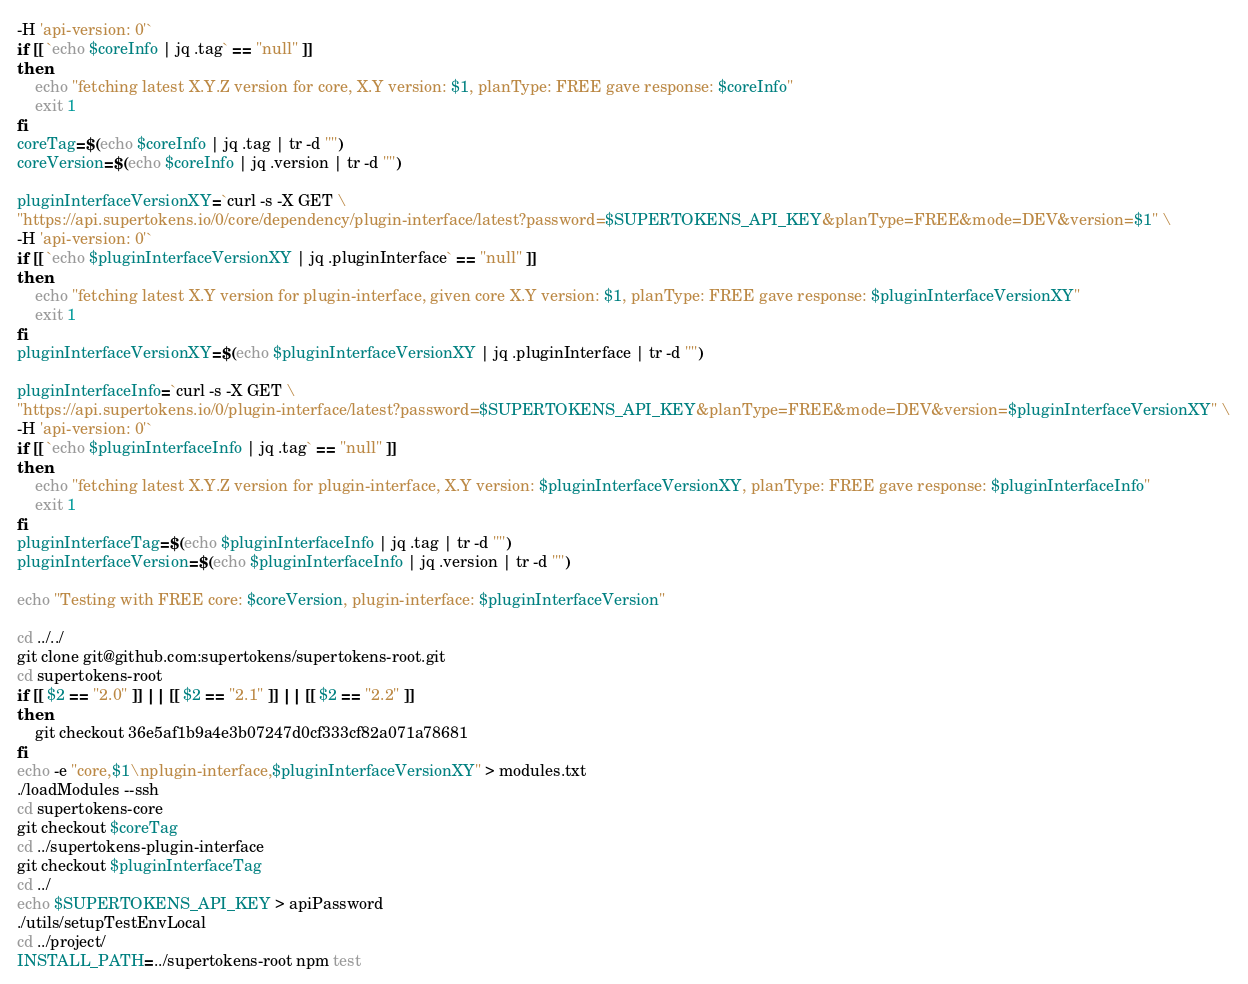<code> <loc_0><loc_0><loc_500><loc_500><_Bash_>-H 'api-version: 0'`
if [[ `echo $coreInfo | jq .tag` == "null" ]]
then
    echo "fetching latest X.Y.Z version for core, X.Y version: $1, planType: FREE gave response: $coreInfo"
    exit 1
fi
coreTag=$(echo $coreInfo | jq .tag | tr -d '"')
coreVersion=$(echo $coreInfo | jq .version | tr -d '"')

pluginInterfaceVersionXY=`curl -s -X GET \
"https://api.supertokens.io/0/core/dependency/plugin-interface/latest?password=$SUPERTOKENS_API_KEY&planType=FREE&mode=DEV&version=$1" \
-H 'api-version: 0'`
if [[ `echo $pluginInterfaceVersionXY | jq .pluginInterface` == "null" ]]
then
    echo "fetching latest X.Y version for plugin-interface, given core X.Y version: $1, planType: FREE gave response: $pluginInterfaceVersionXY"
    exit 1
fi
pluginInterfaceVersionXY=$(echo $pluginInterfaceVersionXY | jq .pluginInterface | tr -d '"')

pluginInterfaceInfo=`curl -s -X GET \
"https://api.supertokens.io/0/plugin-interface/latest?password=$SUPERTOKENS_API_KEY&planType=FREE&mode=DEV&version=$pluginInterfaceVersionXY" \
-H 'api-version: 0'`
if [[ `echo $pluginInterfaceInfo | jq .tag` == "null" ]]
then
    echo "fetching latest X.Y.Z version for plugin-interface, X.Y version: $pluginInterfaceVersionXY, planType: FREE gave response: $pluginInterfaceInfo"
    exit 1
fi
pluginInterfaceTag=$(echo $pluginInterfaceInfo | jq .tag | tr -d '"')
pluginInterfaceVersion=$(echo $pluginInterfaceInfo | jq .version | tr -d '"')

echo "Testing with FREE core: $coreVersion, plugin-interface: $pluginInterfaceVersion"

cd ../../
git clone git@github.com:supertokens/supertokens-root.git
cd supertokens-root
if [[ $2 == "2.0" ]] || [[ $2 == "2.1" ]] || [[ $2 == "2.2" ]]
then
    git checkout 36e5af1b9a4e3b07247d0cf333cf82a071a78681
fi
echo -e "core,$1\nplugin-interface,$pluginInterfaceVersionXY" > modules.txt
./loadModules --ssh
cd supertokens-core
git checkout $coreTag
cd ../supertokens-plugin-interface
git checkout $pluginInterfaceTag
cd ../
echo $SUPERTOKENS_API_KEY > apiPassword
./utils/setupTestEnvLocal
cd ../project/
INSTALL_PATH=../supertokens-root npm test</code> 